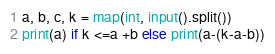<code> <loc_0><loc_0><loc_500><loc_500><_Python_>a, b, c, k = map(int, input().split())
print(a) if k <=a +b else print(a-(k-a-b))</code> 